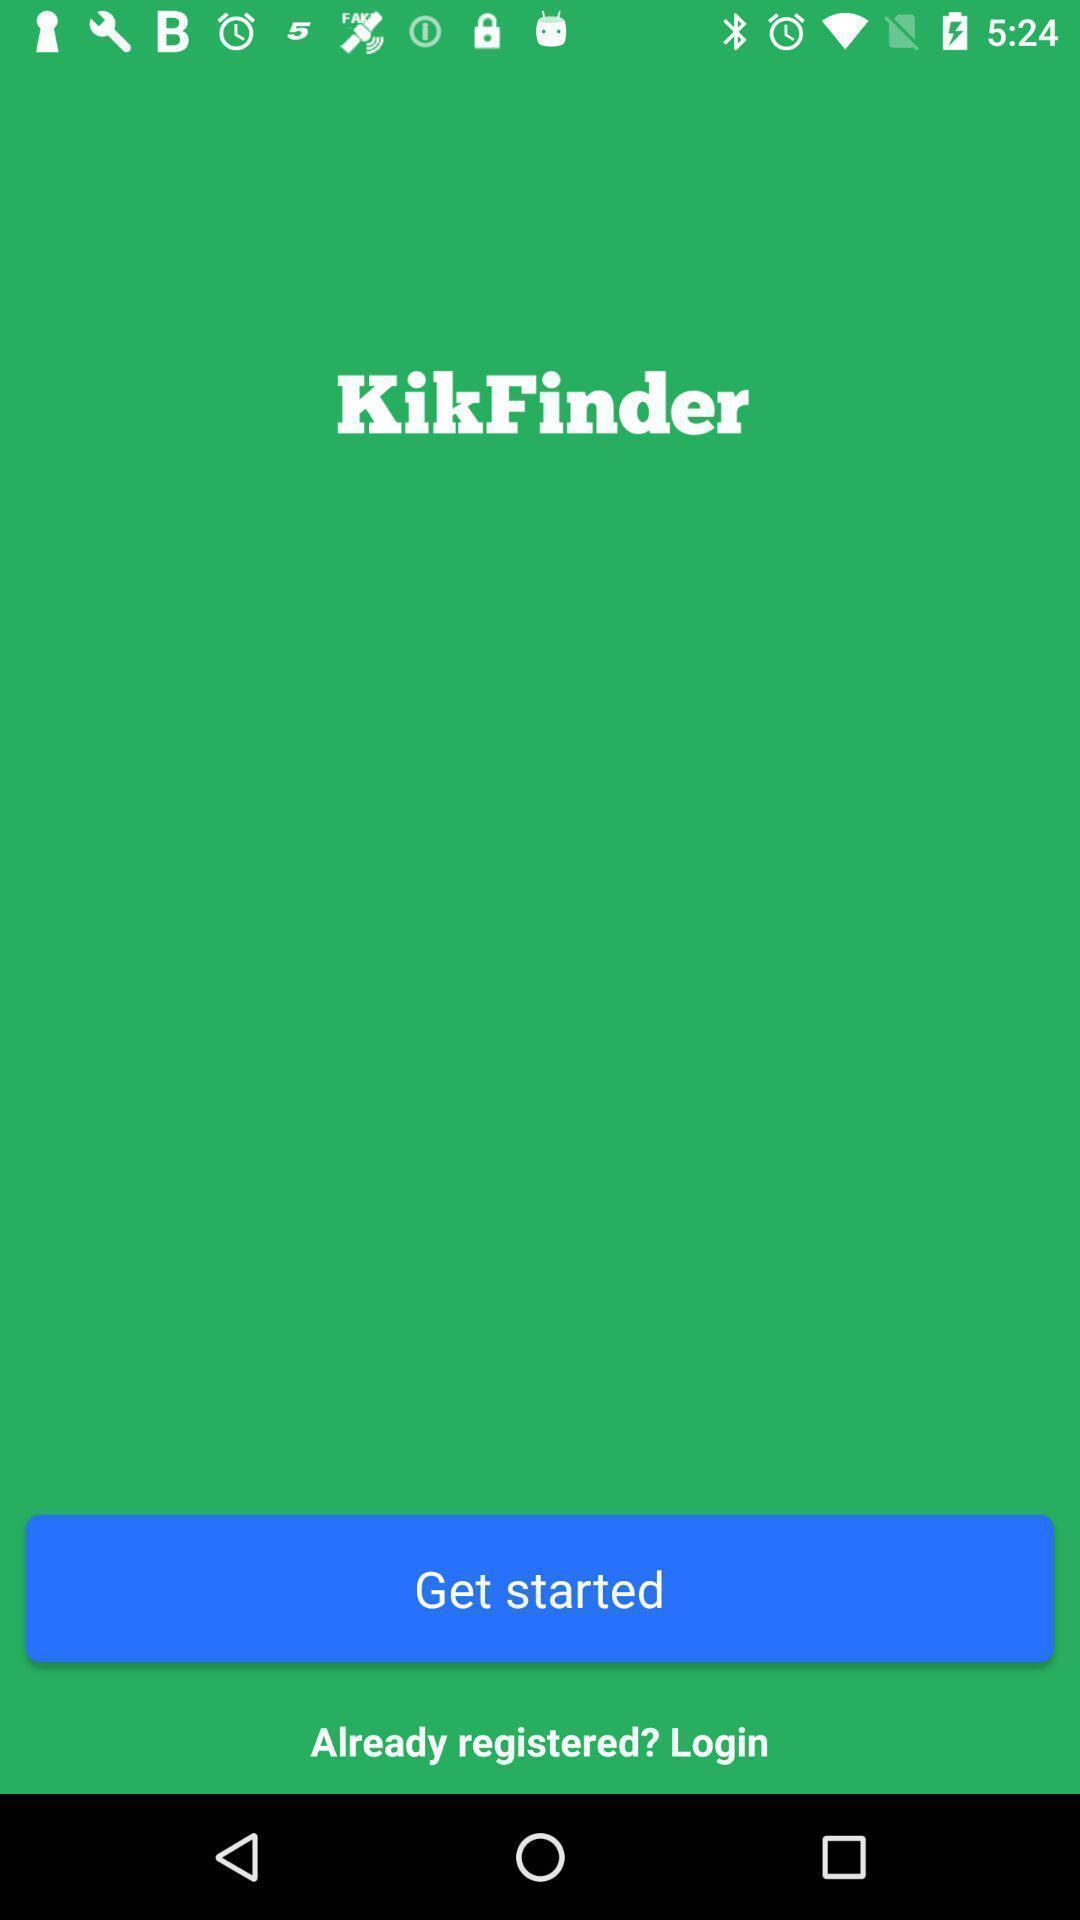Give me a narrative description of this picture. Welcome page to get started. 